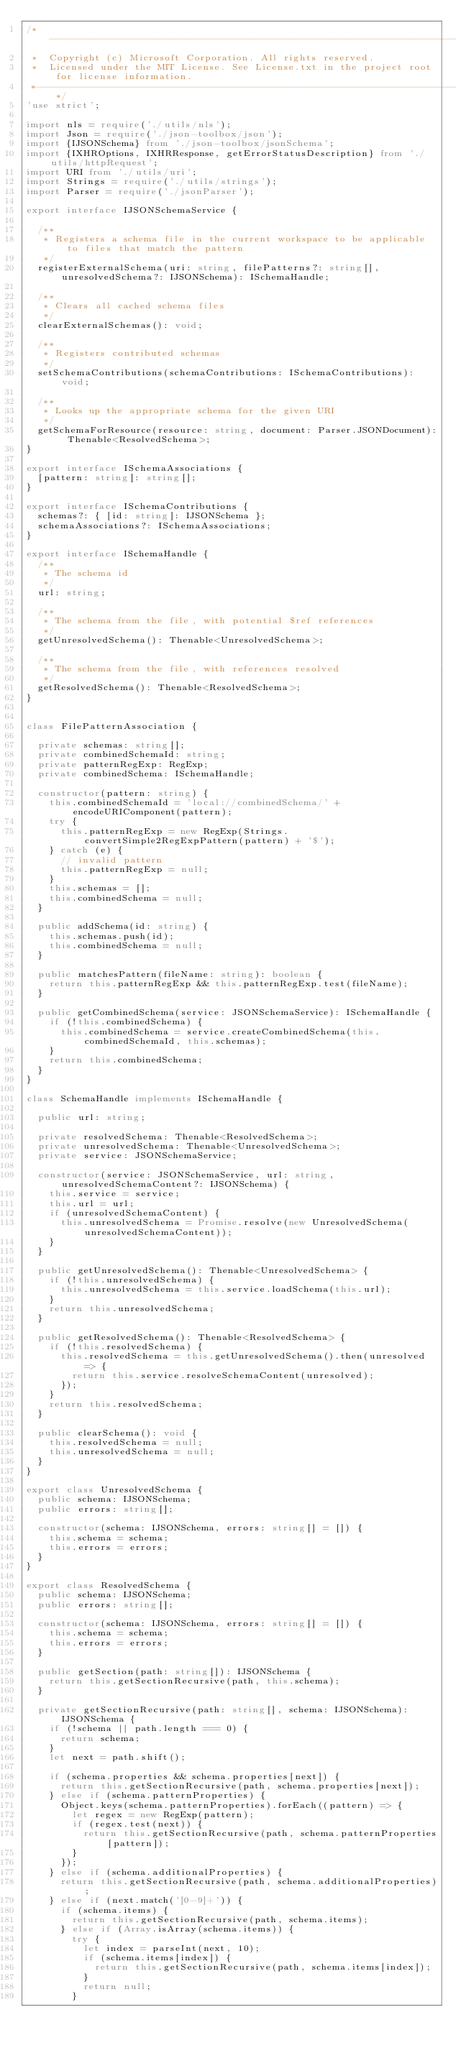<code> <loc_0><loc_0><loc_500><loc_500><_TypeScript_>/*---------------------------------------------------------------------------------------------
 *  Copyright (c) Microsoft Corporation. All rights reserved.
 *  Licensed under the MIT License. See License.txt in the project root for license information.
 *--------------------------------------------------------------------------------------------*/
'use strict';

import nls = require('./utils/nls');
import Json = require('./json-toolbox/json');
import {IJSONSchema} from './json-toolbox/jsonSchema';
import {IXHROptions, IXHRResponse, getErrorStatusDescription} from './utils/httpRequest';
import URI from './utils/uri';
import Strings = require('./utils/strings');
import Parser = require('./jsonParser');

export interface IJSONSchemaService {

	/**
	 * Registers a schema file in the current workspace to be applicable to files that match the pattern
	 */
	registerExternalSchema(uri: string, filePatterns?: string[], unresolvedSchema?: IJSONSchema): ISchemaHandle;

	/**
	 * Clears all cached schema files
	 */
	clearExternalSchemas(): void;

	/**
	 * Registers contributed schemas
	 */
	setSchemaContributions(schemaContributions: ISchemaContributions): void;

	/**
	 * Looks up the appropriate schema for the given URI
	 */
	getSchemaForResource(resource: string, document: Parser.JSONDocument): Thenable<ResolvedSchema>;
}

export interface ISchemaAssociations {
	[pattern: string]: string[];
}

export interface ISchemaContributions {
	schemas?: { [id: string]: IJSONSchema };
	schemaAssociations?: ISchemaAssociations;
}

export interface ISchemaHandle {
	/**
	 * The schema id
	 */
	url: string;

	/**
	 * The schema from the file, with potential $ref references
	 */
	getUnresolvedSchema(): Thenable<UnresolvedSchema>;

	/**
	 * The schema from the file, with references resolved
	 */
	getResolvedSchema(): Thenable<ResolvedSchema>;
}


class FilePatternAssociation {

	private schemas: string[];
	private combinedSchemaId: string;
	private patternRegExp: RegExp;
	private combinedSchema: ISchemaHandle;

	constructor(pattern: string) {
		this.combinedSchemaId = 'local://combinedSchema/' + encodeURIComponent(pattern);
		try {
			this.patternRegExp = new RegExp(Strings.convertSimple2RegExpPattern(pattern) + '$');
		} catch (e) {
			// invalid pattern
			this.patternRegExp = null;
		}
		this.schemas = [];
		this.combinedSchema = null;
	}

	public addSchema(id: string) {
		this.schemas.push(id);
		this.combinedSchema = null;
	}

	public matchesPattern(fileName: string): boolean {
		return this.patternRegExp && this.patternRegExp.test(fileName);
	}

	public getCombinedSchema(service: JSONSchemaService): ISchemaHandle {
		if (!this.combinedSchema) {
			this.combinedSchema = service.createCombinedSchema(this.combinedSchemaId, this.schemas);
		}
		return this.combinedSchema;
	}
}

class SchemaHandle implements ISchemaHandle {

	public url: string;

	private resolvedSchema: Thenable<ResolvedSchema>;
	private unresolvedSchema: Thenable<UnresolvedSchema>;
	private service: JSONSchemaService;

	constructor(service: JSONSchemaService, url: string, unresolvedSchemaContent?: IJSONSchema) {
		this.service = service;
		this.url = url;
		if (unresolvedSchemaContent) {
			this.unresolvedSchema = Promise.resolve(new UnresolvedSchema(unresolvedSchemaContent));
		}
	}

	public getUnresolvedSchema(): Thenable<UnresolvedSchema> {
		if (!this.unresolvedSchema) {
			this.unresolvedSchema = this.service.loadSchema(this.url);
		}
		return this.unresolvedSchema;
	}

	public getResolvedSchema(): Thenable<ResolvedSchema> {
		if (!this.resolvedSchema) {
			this.resolvedSchema = this.getUnresolvedSchema().then(unresolved => {
				return this.service.resolveSchemaContent(unresolved);
			});
		}
		return this.resolvedSchema;
	}

	public clearSchema(): void {
		this.resolvedSchema = null;
		this.unresolvedSchema = null;
	}
}

export class UnresolvedSchema {
	public schema: IJSONSchema;
	public errors: string[];

	constructor(schema: IJSONSchema, errors: string[] = []) {
		this.schema = schema;
		this.errors = errors;
	}
}

export class ResolvedSchema {
	public schema: IJSONSchema;
	public errors: string[];

	constructor(schema: IJSONSchema, errors: string[] = []) {
		this.schema = schema;
		this.errors = errors;
	}

	public getSection(path: string[]): IJSONSchema {
		return this.getSectionRecursive(path, this.schema);
	}

	private getSectionRecursive(path: string[], schema: IJSONSchema): IJSONSchema {
		if (!schema || path.length === 0) {
			return schema;
		}
		let next = path.shift();

		if (schema.properties && schema.properties[next]) {
			return this.getSectionRecursive(path, schema.properties[next]);
		} else if (schema.patternProperties) {
			Object.keys(schema.patternProperties).forEach((pattern) => {
				let regex = new RegExp(pattern);
				if (regex.test(next)) {
					return this.getSectionRecursive(path, schema.patternProperties[pattern]);
				}
			});
		} else if (schema.additionalProperties) {
			return this.getSectionRecursive(path, schema.additionalProperties);
		} else if (next.match('[0-9]+')) {
			if (schema.items) {
				return this.getSectionRecursive(path, schema.items);
			} else if (Array.isArray(schema.items)) {
				try {
					let index = parseInt(next, 10);
					if (schema.items[index]) {
						return this.getSectionRecursive(path, schema.items[index]);
					}
					return null;
				}</code> 